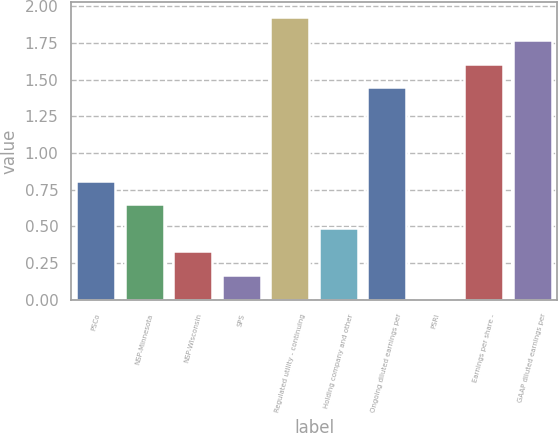Convert chart. <chart><loc_0><loc_0><loc_500><loc_500><bar_chart><fcel>PSCo<fcel>NSP-Minnesota<fcel>NSP-Wisconsin<fcel>SPS<fcel>Regulated utility - continuing<fcel>Holding company and other<fcel>Ongoing diluted earnings per<fcel>PSRI<fcel>Earnings per share -<fcel>GAAP diluted earnings per<nl><fcel>0.81<fcel>0.65<fcel>0.33<fcel>0.17<fcel>1.93<fcel>0.49<fcel>1.45<fcel>0.01<fcel>1.61<fcel>1.77<nl></chart> 